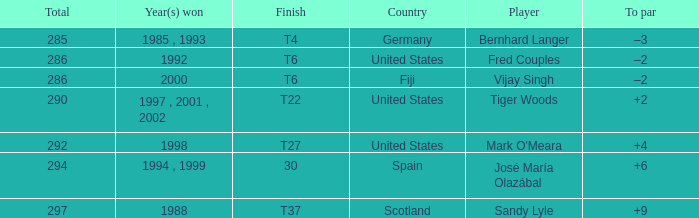What is the total for Bernhard Langer? 1.0. 